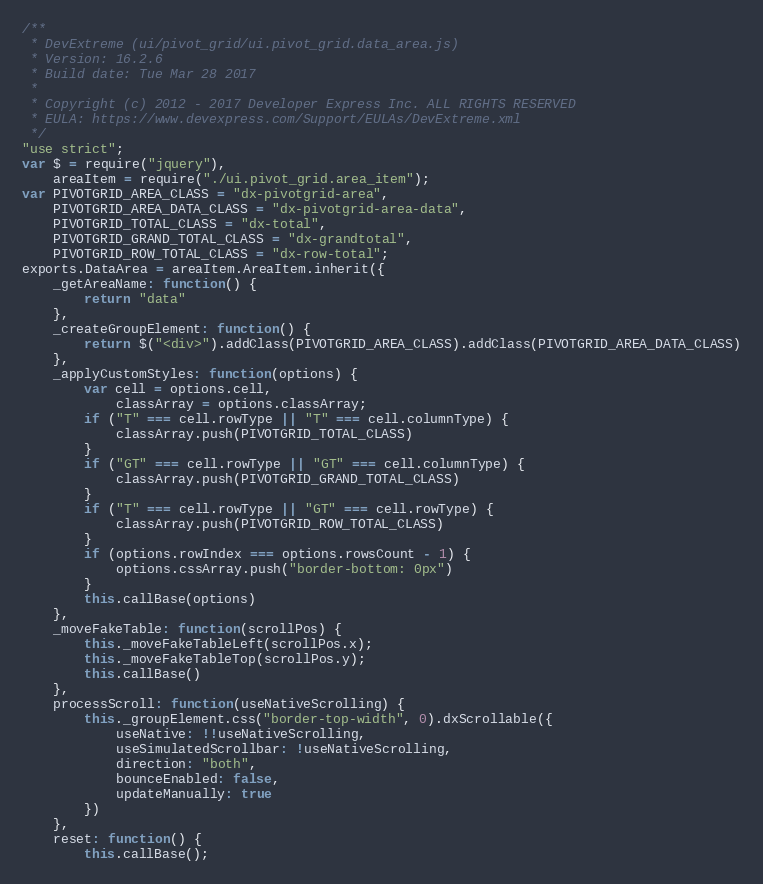Convert code to text. <code><loc_0><loc_0><loc_500><loc_500><_JavaScript_>/**
 * DevExtreme (ui/pivot_grid/ui.pivot_grid.data_area.js)
 * Version: 16.2.6
 * Build date: Tue Mar 28 2017
 *
 * Copyright (c) 2012 - 2017 Developer Express Inc. ALL RIGHTS RESERVED
 * EULA: https://www.devexpress.com/Support/EULAs/DevExtreme.xml
 */
"use strict";
var $ = require("jquery"),
    areaItem = require("./ui.pivot_grid.area_item");
var PIVOTGRID_AREA_CLASS = "dx-pivotgrid-area",
    PIVOTGRID_AREA_DATA_CLASS = "dx-pivotgrid-area-data",
    PIVOTGRID_TOTAL_CLASS = "dx-total",
    PIVOTGRID_GRAND_TOTAL_CLASS = "dx-grandtotal",
    PIVOTGRID_ROW_TOTAL_CLASS = "dx-row-total";
exports.DataArea = areaItem.AreaItem.inherit({
    _getAreaName: function() {
        return "data"
    },
    _createGroupElement: function() {
        return $("<div>").addClass(PIVOTGRID_AREA_CLASS).addClass(PIVOTGRID_AREA_DATA_CLASS)
    },
    _applyCustomStyles: function(options) {
        var cell = options.cell,
            classArray = options.classArray;
        if ("T" === cell.rowType || "T" === cell.columnType) {
            classArray.push(PIVOTGRID_TOTAL_CLASS)
        }
        if ("GT" === cell.rowType || "GT" === cell.columnType) {
            classArray.push(PIVOTGRID_GRAND_TOTAL_CLASS)
        }
        if ("T" === cell.rowType || "GT" === cell.rowType) {
            classArray.push(PIVOTGRID_ROW_TOTAL_CLASS)
        }
        if (options.rowIndex === options.rowsCount - 1) {
            options.cssArray.push("border-bottom: 0px")
        }
        this.callBase(options)
    },
    _moveFakeTable: function(scrollPos) {
        this._moveFakeTableLeft(scrollPos.x);
        this._moveFakeTableTop(scrollPos.y);
        this.callBase()
    },
    processScroll: function(useNativeScrolling) {
        this._groupElement.css("border-top-width", 0).dxScrollable({
            useNative: !!useNativeScrolling,
            useSimulatedScrollbar: !useNativeScrolling,
            direction: "both",
            bounceEnabled: false,
            updateManually: true
        })
    },
    reset: function() {
        this.callBase();</code> 